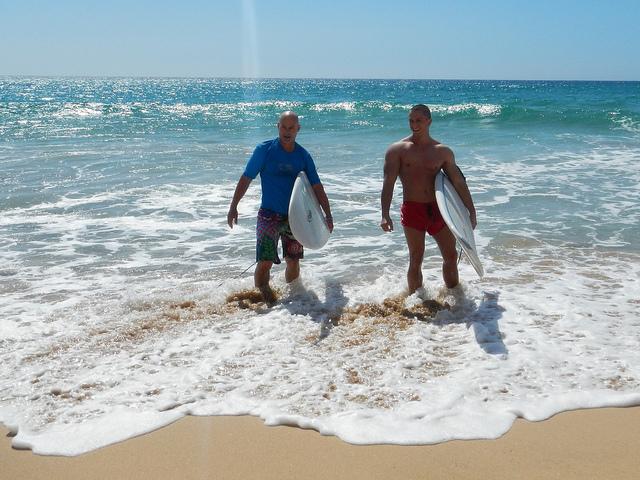Which man looks as if he is a weightlifter?
Write a very short answer. Man on right. Which man is in blue?
Give a very brief answer. Left. How many men are shirtless?
Write a very short answer. 1. 